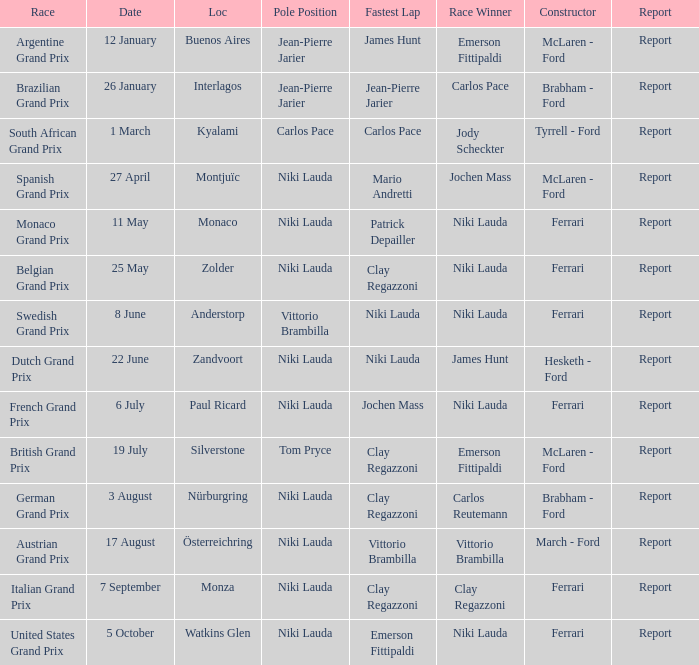Where did the team in which Tom Pryce was in Pole Position race? Silverstone. 